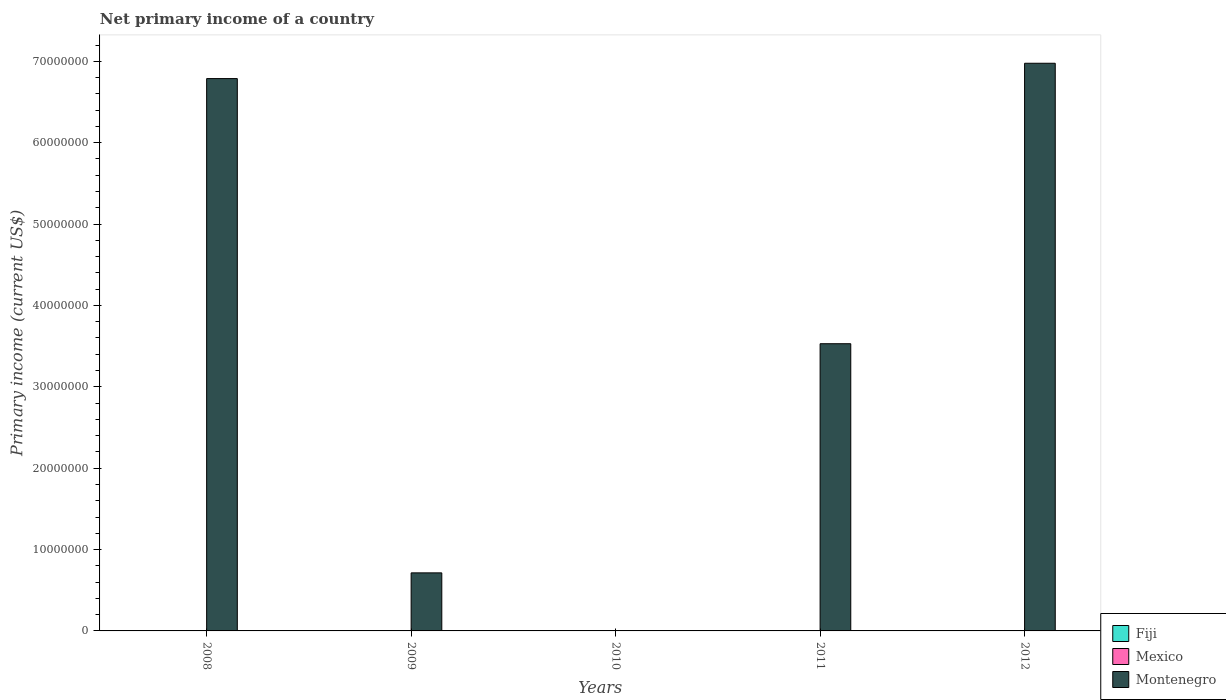How many different coloured bars are there?
Ensure brevity in your answer.  1. Are the number of bars per tick equal to the number of legend labels?
Your answer should be compact. No. How many bars are there on the 2nd tick from the left?
Give a very brief answer. 1. How many bars are there on the 5th tick from the right?
Offer a terse response. 1. What is the label of the 3rd group of bars from the left?
Your answer should be compact. 2010. What is the primary income in Mexico in 2010?
Keep it short and to the point. 0. Across all years, what is the maximum primary income in Montenegro?
Your answer should be very brief. 6.98e+07. What is the total primary income in Mexico in the graph?
Make the answer very short. 0. What is the difference between the primary income in Montenegro in 2009 and that in 2011?
Offer a terse response. -2.82e+07. What is the difference between the primary income in Fiji in 2011 and the primary income in Mexico in 2008?
Make the answer very short. 0. What is the average primary income in Mexico per year?
Your response must be concise. 0. What is the ratio of the primary income in Montenegro in 2008 to that in 2011?
Keep it short and to the point. 1.92. What is the difference between the highest and the second highest primary income in Montenegro?
Provide a short and direct response. 1.88e+06. What is the difference between the highest and the lowest primary income in Montenegro?
Your response must be concise. 6.98e+07. Is the sum of the primary income in Montenegro in 2008 and 2012 greater than the maximum primary income in Fiji across all years?
Your answer should be compact. Yes. Is it the case that in every year, the sum of the primary income in Fiji and primary income in Montenegro is greater than the primary income in Mexico?
Give a very brief answer. No. How many bars are there?
Your answer should be compact. 4. Are all the bars in the graph horizontal?
Your response must be concise. No. How many years are there in the graph?
Provide a short and direct response. 5. What is the difference between two consecutive major ticks on the Y-axis?
Your answer should be very brief. 1.00e+07. Where does the legend appear in the graph?
Your response must be concise. Bottom right. How many legend labels are there?
Ensure brevity in your answer.  3. What is the title of the graph?
Give a very brief answer. Net primary income of a country. Does "Korea (Republic)" appear as one of the legend labels in the graph?
Your response must be concise. No. What is the label or title of the X-axis?
Make the answer very short. Years. What is the label or title of the Y-axis?
Offer a very short reply. Primary income (current US$). What is the Primary income (current US$) in Mexico in 2008?
Keep it short and to the point. 0. What is the Primary income (current US$) in Montenegro in 2008?
Make the answer very short. 6.79e+07. What is the Primary income (current US$) of Fiji in 2009?
Offer a very short reply. 0. What is the Primary income (current US$) of Montenegro in 2009?
Give a very brief answer. 7.13e+06. What is the Primary income (current US$) in Fiji in 2011?
Offer a terse response. 0. What is the Primary income (current US$) in Montenegro in 2011?
Provide a succinct answer. 3.53e+07. What is the Primary income (current US$) in Mexico in 2012?
Keep it short and to the point. 0. What is the Primary income (current US$) in Montenegro in 2012?
Your answer should be very brief. 6.98e+07. Across all years, what is the maximum Primary income (current US$) of Montenegro?
Offer a very short reply. 6.98e+07. Across all years, what is the minimum Primary income (current US$) of Montenegro?
Provide a succinct answer. 0. What is the total Primary income (current US$) of Fiji in the graph?
Make the answer very short. 0. What is the total Primary income (current US$) in Mexico in the graph?
Provide a short and direct response. 0. What is the total Primary income (current US$) in Montenegro in the graph?
Give a very brief answer. 1.80e+08. What is the difference between the Primary income (current US$) of Montenegro in 2008 and that in 2009?
Ensure brevity in your answer.  6.07e+07. What is the difference between the Primary income (current US$) in Montenegro in 2008 and that in 2011?
Provide a succinct answer. 3.26e+07. What is the difference between the Primary income (current US$) in Montenegro in 2008 and that in 2012?
Offer a terse response. -1.88e+06. What is the difference between the Primary income (current US$) of Montenegro in 2009 and that in 2011?
Your answer should be compact. -2.82e+07. What is the difference between the Primary income (current US$) of Montenegro in 2009 and that in 2012?
Give a very brief answer. -6.26e+07. What is the difference between the Primary income (current US$) in Montenegro in 2011 and that in 2012?
Make the answer very short. -3.45e+07. What is the average Primary income (current US$) of Montenegro per year?
Your response must be concise. 3.60e+07. What is the ratio of the Primary income (current US$) in Montenegro in 2008 to that in 2009?
Ensure brevity in your answer.  9.51. What is the ratio of the Primary income (current US$) of Montenegro in 2008 to that in 2011?
Keep it short and to the point. 1.92. What is the ratio of the Primary income (current US$) in Montenegro in 2009 to that in 2011?
Give a very brief answer. 0.2. What is the ratio of the Primary income (current US$) of Montenegro in 2009 to that in 2012?
Your answer should be very brief. 0.1. What is the ratio of the Primary income (current US$) in Montenegro in 2011 to that in 2012?
Give a very brief answer. 0.51. What is the difference between the highest and the second highest Primary income (current US$) of Montenegro?
Offer a very short reply. 1.88e+06. What is the difference between the highest and the lowest Primary income (current US$) of Montenegro?
Provide a short and direct response. 6.98e+07. 